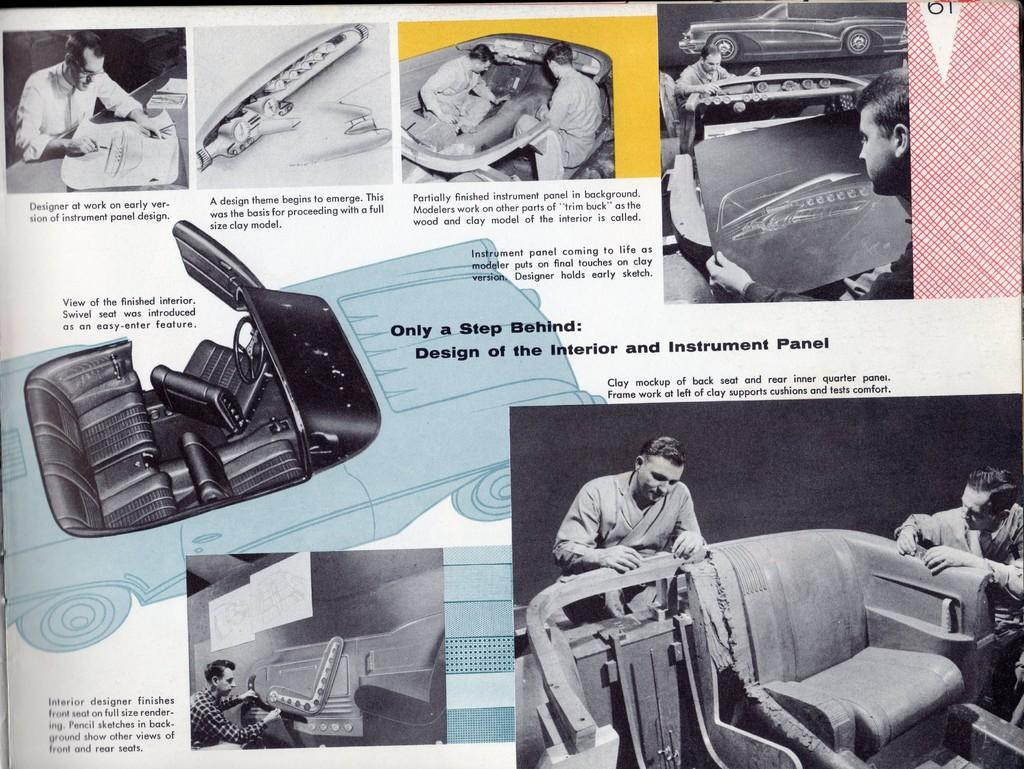What type of content is on the paper in the image? There is a paper with text in the image. What else can be seen in the image besides the paper? There are images of people and vehicles in the image. Can you describe any other objects present in the image? Yes, there are other objects present in the image. How many pins are holding the paper to the wall in the image? There is no information about pins or the paper being attached to a wall in the image. 